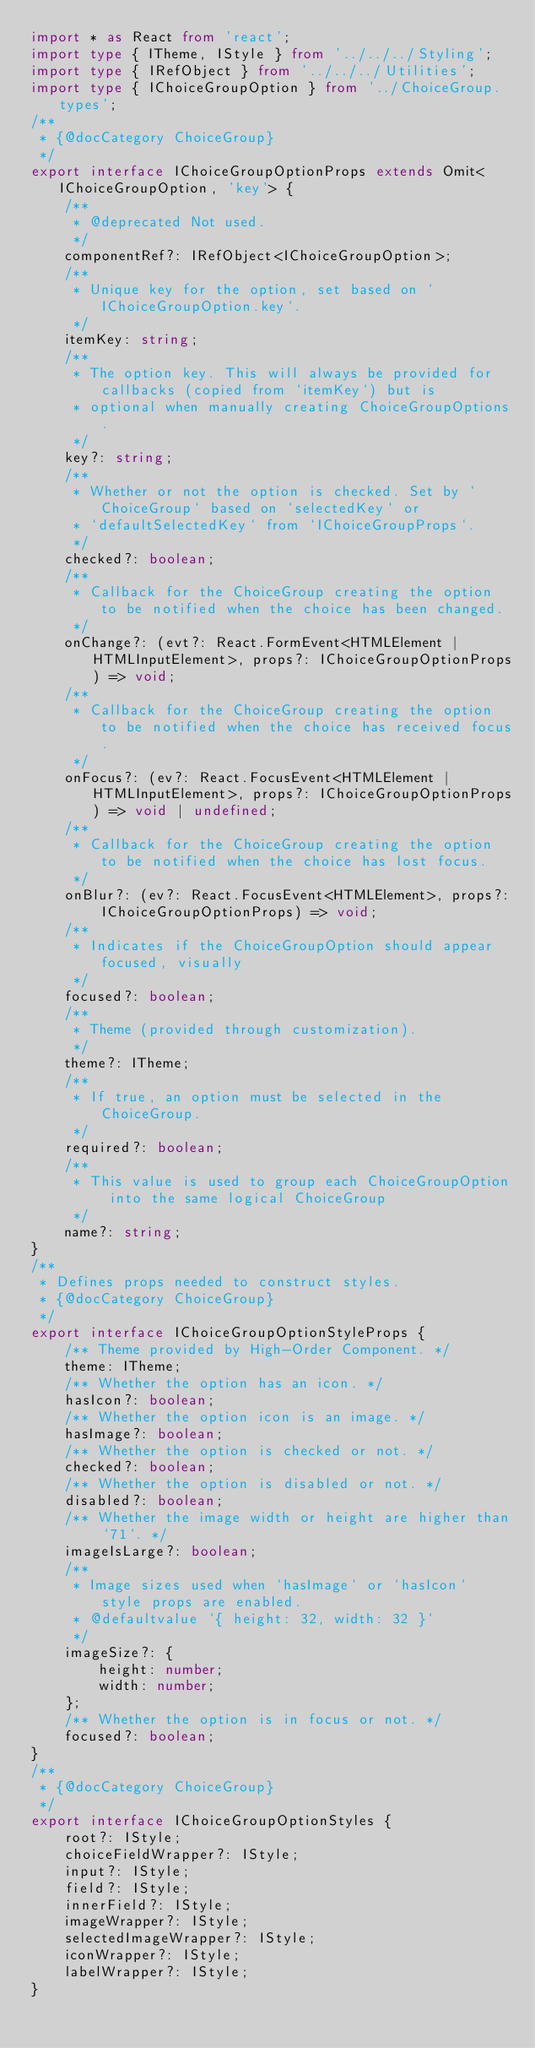Convert code to text. <code><loc_0><loc_0><loc_500><loc_500><_TypeScript_>import * as React from 'react';
import type { ITheme, IStyle } from '../../../Styling';
import type { IRefObject } from '../../../Utilities';
import type { IChoiceGroupOption } from '../ChoiceGroup.types';
/**
 * {@docCategory ChoiceGroup}
 */
export interface IChoiceGroupOptionProps extends Omit<IChoiceGroupOption, 'key'> {
    /**
     * @deprecated Not used.
     */
    componentRef?: IRefObject<IChoiceGroupOption>;
    /**
     * Unique key for the option, set based on `IChoiceGroupOption.key`.
     */
    itemKey: string;
    /**
     * The option key. This will always be provided for callbacks (copied from `itemKey`) but is
     * optional when manually creating ChoiceGroupOptions.
     */
    key?: string;
    /**
     * Whether or not the option is checked. Set by `ChoiceGroup` based on `selectedKey` or
     * `defaultSelectedKey` from `IChoiceGroupProps`.
     */
    checked?: boolean;
    /**
     * Callback for the ChoiceGroup creating the option to be notified when the choice has been changed.
     */
    onChange?: (evt?: React.FormEvent<HTMLElement | HTMLInputElement>, props?: IChoiceGroupOptionProps) => void;
    /**
     * Callback for the ChoiceGroup creating the option to be notified when the choice has received focus.
     */
    onFocus?: (ev?: React.FocusEvent<HTMLElement | HTMLInputElement>, props?: IChoiceGroupOptionProps) => void | undefined;
    /**
     * Callback for the ChoiceGroup creating the option to be notified when the choice has lost focus.
     */
    onBlur?: (ev?: React.FocusEvent<HTMLElement>, props?: IChoiceGroupOptionProps) => void;
    /**
     * Indicates if the ChoiceGroupOption should appear focused, visually
     */
    focused?: boolean;
    /**
     * Theme (provided through customization).
     */
    theme?: ITheme;
    /**
     * If true, an option must be selected in the ChoiceGroup.
     */
    required?: boolean;
    /**
     * This value is used to group each ChoiceGroupOption into the same logical ChoiceGroup
     */
    name?: string;
}
/**
 * Defines props needed to construct styles.
 * {@docCategory ChoiceGroup}
 */
export interface IChoiceGroupOptionStyleProps {
    /** Theme provided by High-Order Component. */
    theme: ITheme;
    /** Whether the option has an icon. */
    hasIcon?: boolean;
    /** Whether the option icon is an image. */
    hasImage?: boolean;
    /** Whether the option is checked or not. */
    checked?: boolean;
    /** Whether the option is disabled or not. */
    disabled?: boolean;
    /** Whether the image width or height are higher than `71`. */
    imageIsLarge?: boolean;
    /**
     * Image sizes used when `hasImage` or `hasIcon` style props are enabled.
     * @defaultvalue `{ height: 32, width: 32 }`
     */
    imageSize?: {
        height: number;
        width: number;
    };
    /** Whether the option is in focus or not. */
    focused?: boolean;
}
/**
 * {@docCategory ChoiceGroup}
 */
export interface IChoiceGroupOptionStyles {
    root?: IStyle;
    choiceFieldWrapper?: IStyle;
    input?: IStyle;
    field?: IStyle;
    innerField?: IStyle;
    imageWrapper?: IStyle;
    selectedImageWrapper?: IStyle;
    iconWrapper?: IStyle;
    labelWrapper?: IStyle;
}
</code> 